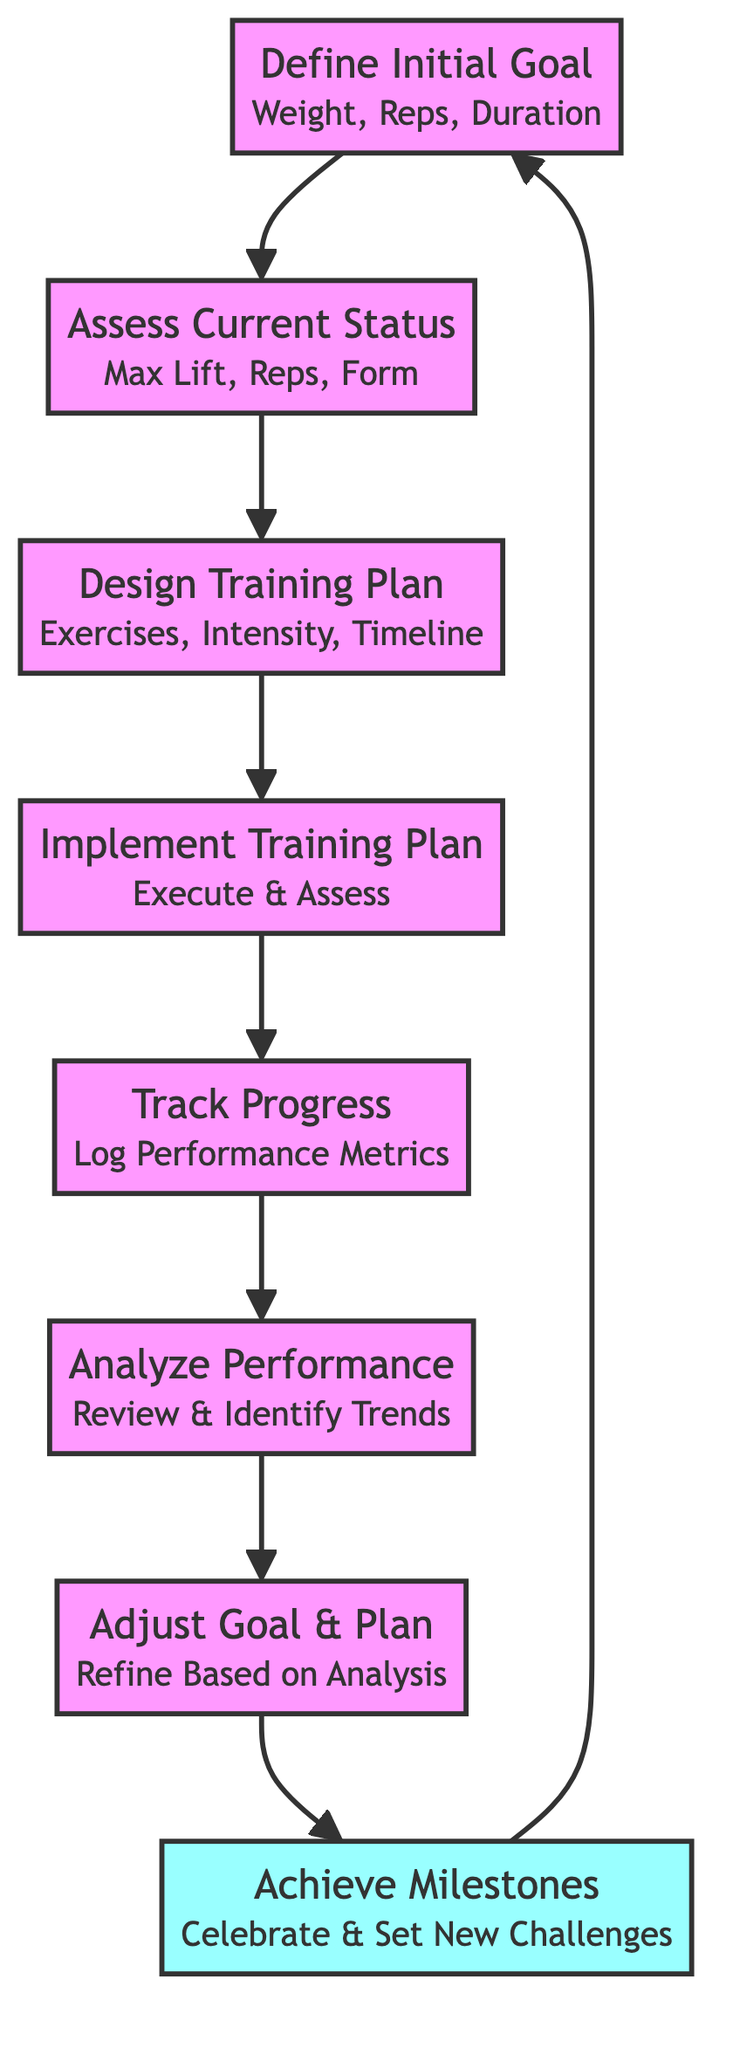What is the first step in this process? The first step in the flowchart is labeled "Define Initial Goal," indicating that it is the starting point of the function.
Answer: Define Initial Goal How many nodes are present in the diagram? By counting the individual steps described in the flowchart, we find there are eight nodes corresponding to each phase of the goal-setting and progress tracking process.
Answer: Eight What inputs are required for the "Assess Current Status" step? The "Assess Current Status" node lists three specific inputs needed: current maximum lift, current reps, and current form.
Answer: Current Max Lift, Current Reps, Current Form What outputs arise from the "Analyze Performance"? The "Analyze Performance" node provides two outputs: performance analysis and adjustments as results of reviewing the logged progress reports.
Answer: Performance Analysis, Adjustments What is the relationship between "Track Progress" and "Implement Training Plan"? The "Track Progress" node immediately follows "Implement Training Plan" in the flowchart, showing a sequential relationship where progress tracking occurs after the training plan has been put into action.
Answer: Sequential Relationship What happens after the "Achieve Milestones" step? Following the "Achieve Milestones" node, the flowchart loops back to "Define Initial Goal," indicating that once milestones are achieved, the process restarts with goal definition.
Answer: Restart Process Which steps use performance data as an input? The "Track Progress" and "Analyze Performance" nodes utilize performance data as their input, utilizing it for monitoring and analyzing progress.
Answer: Track Progress, Analyze Performance What are the outputs of the "Adjust Goal And Plan"? The outputs generated from the "Adjust Goal And Plan" node are the updated goal and the revised training plan, as part of refining the process based on analysis.
Answer: Updated Goal, Revised Training Plan How many edges connect the nodes in this diagram? Analyzing the flow between each of the eight nodes, there are seven edges that connect the nodes in a single pathway from the start to the end of the process.
Answer: Seven 